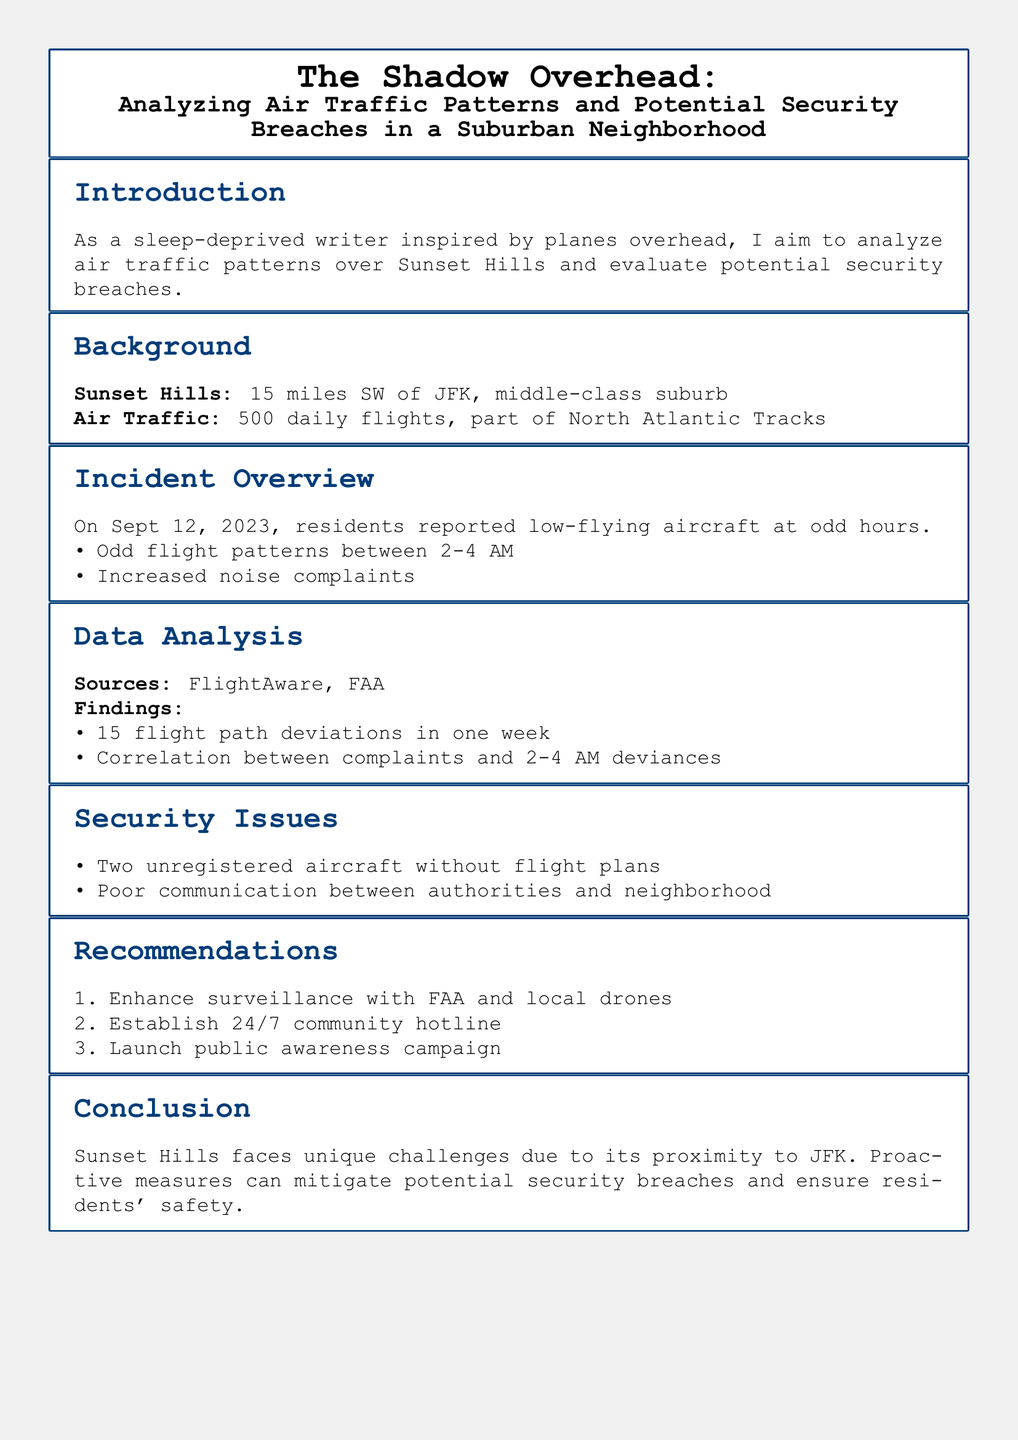What is the location of Sunset Hills? Sunset Hills is described as being 15 miles SW of JFK.
Answer: 15 miles SW of JFK How many daily flights does Sunset Hills experience? The document states that there are 500 daily flights in the vicinity of Sunset Hills.
Answer: 500 What time frame did residents report odd flight patterns? The reported odd flight patterns occurred between 2-4 AM.
Answer: 2-4 AM How many flight path deviations were recorded in one week? The analysis found 15 flight path deviations in one week.
Answer: 15 What was the date of the incident overview? The incidents involving low-flying aircraft were reported on September 12, 2023.
Answer: September 12, 2023 What are the two security issues identified? The document lists two security issues: unregistered aircraft and poor communication between authorities and the neighborhood.
Answer: Unregistered aircraft, poor communication How many recommendations are made in the case study? The recommendations section includes three specific measures to improve the situation.
Answer: 3 What is one of the suggested methods for increasing surveillance? One recommendation is to enhance surveillance with FAA and local drones.
Answer: Local drones What community measure is suggested for better communication? Establishing a 24/7 community hotline is suggested for better communication among residents and authorities.
Answer: 24/7 community hotline 